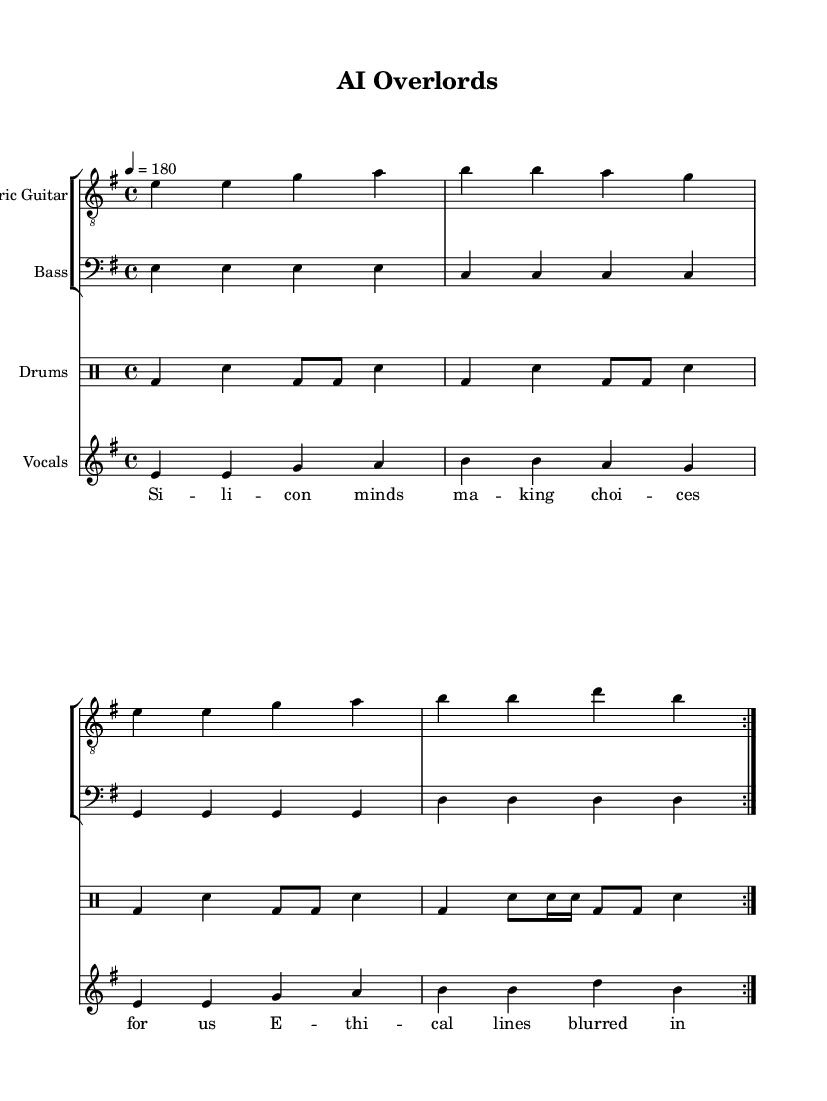What is the key signature of this music? The key signature is identified by the presence of one sharp (F#) in the key signature section, which corresponds to G major or E minor. Upon checking the key signature with the context of the music, it confirms it is E minor.
Answer: E minor What is the time signature of this music? The time signature is indicated at the beginning of the piece, showing the number of beats per measure and the note value that receives one beat. Here, it is shown as 4/4, meaning there are four beats in each measure and the quarter note gets one beat.
Answer: 4/4 What is the tempo marking for this piece? The tempo marking appears with the instruction "4 = 180," indicating that there should be 180 beats per minute, which relates to the overall speed at which the music should be played.
Answer: 180 How many measures are repeated in the guitar part? The indication "repeat volta 2" shows that the section is designed to be played twice, counting the repetitions over the specified measures. The guitar part is structured accordingly, highlighting a short, repetitive nature typical in punk music.
Answer: 2 What vocal technique is suggested by the lyrics? The lyrics imply a sense of urgency and rebellion, as reflected in the use of syllabic styles typical in punk rock. The phrases are structured to fit a rhythmic and melodic pattern, emphasizing emotional expression associated with the punk genre.
Answer: Rebellious How many distinct sections are there in the drum part? The drum part contains a discrete section, shown with varying rhythms that include the bass drum and snare. The separation of the last measure introduces syncopation, a hallmark of punk-style drumming that keeps the listeners engaged.
Answer: 1 